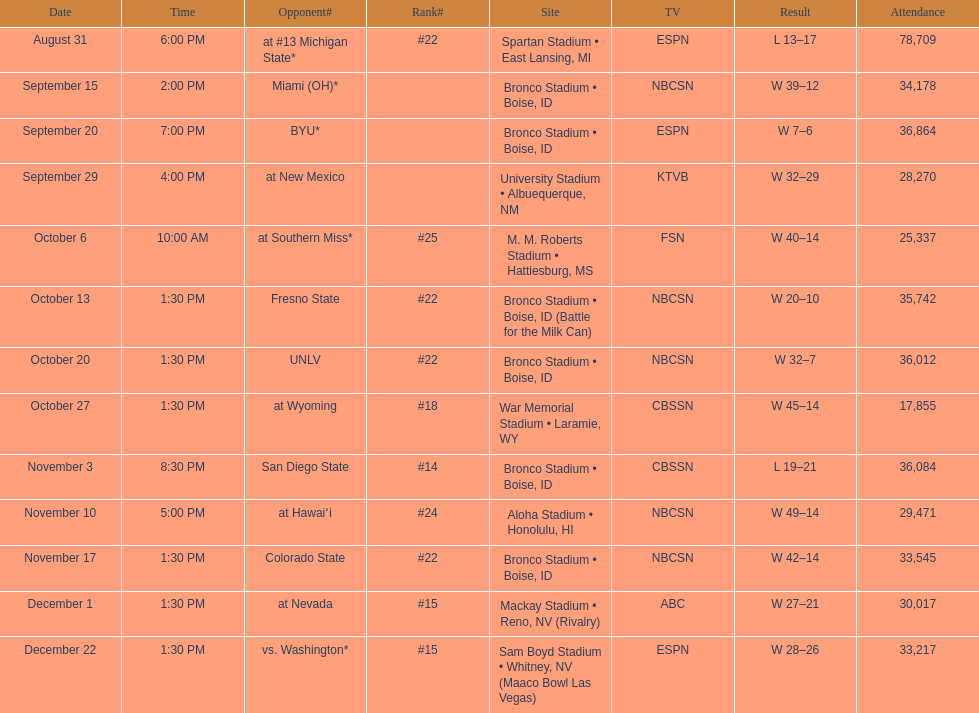Which team possesses the top position among those mentioned? San Diego State. 